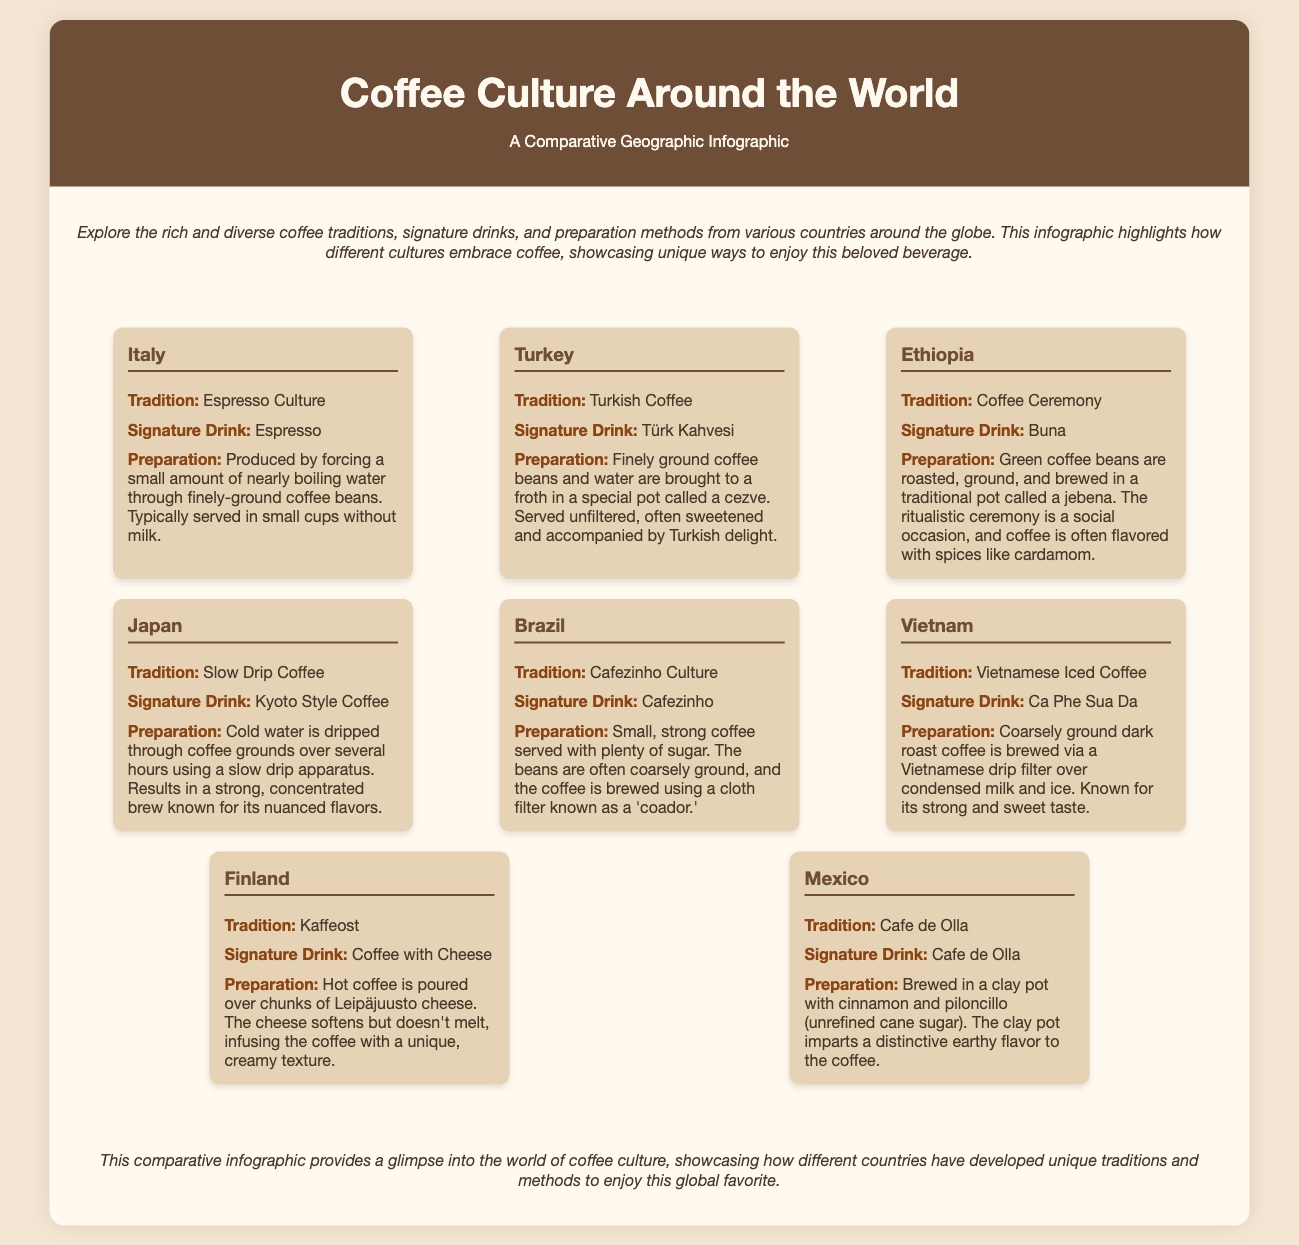what is the signature drink of Italy? The signature drink of Italy, as stated in the document, is Espresso.
Answer: Espresso what is the tradition associated with Ethiopia? In Ethiopia, the tradition highlighted in the document is the Coffee Ceremony.
Answer: Coffee Ceremony how is coffee prepared in Japan? The preparation method for coffee in Japan is described in the document as cold water dripped through coffee grounds over several hours.
Answer: Cold water dripped which country is known for Cafezinho culture? The document mentions Brazil as the country known for Cafezinho Culture.
Answer: Brazil what unique ingredient is used in Finland's coffee tradition? The unique ingredient mentioned in Finland's coffee tradition is Leipäjuusto cheese.
Answer: Leipäjuusto cheese what is the preparation method for Turkish Coffee? The preparation method for Turkish Coffee involves bringing finely ground coffee and water to a froth in a cezve.
Answer: Cezve which country's signature drink is brewed in a clay pot? The document states that Mexico's signature drink, Cafe de Olla, is brewed in a clay pot.
Answer: Mexico how many countries are featured in the infographic? The document features a total of 8 countries in the infographic.
Answer: 8 